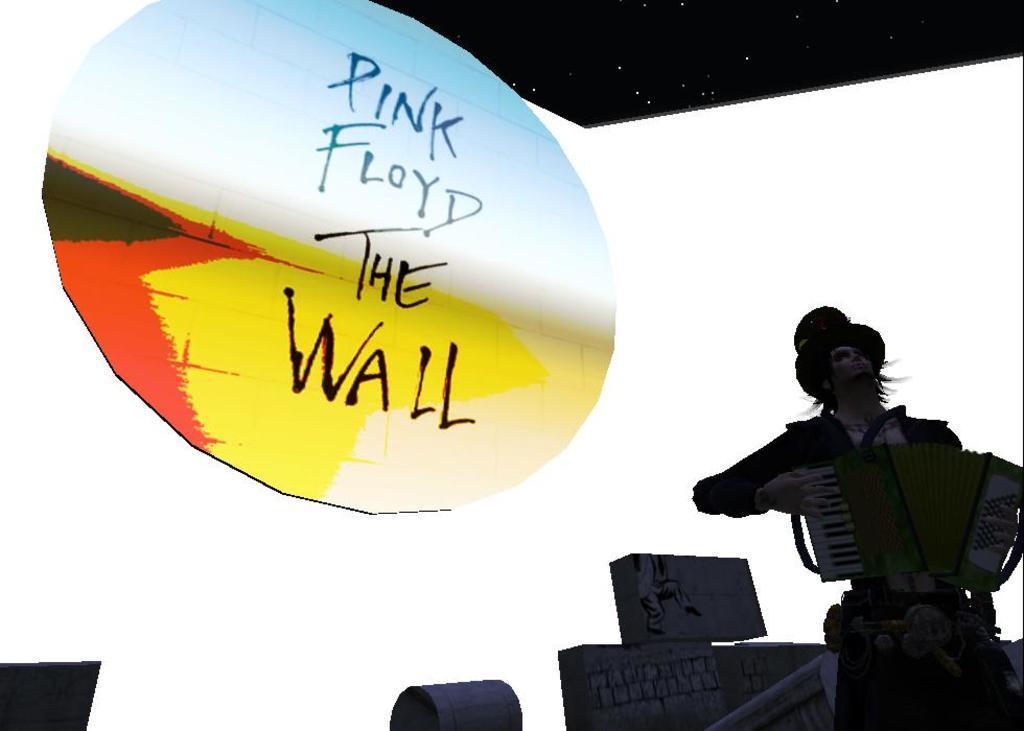What type of picture is in the image? There is an animated picture in the image. What is happening in the animated picture? A person is standing in the animated picture, holding a musical instrument. What can be seen in the animated picture besides the person? There is a huge board in the animated picture, with a white surface. How is the sky depicted in the animated picture? The sky in the animated picture is dark. What type of liquid is being poured on the person's legs in the image? There is no liquid being poured on the person's legs in the image, as the provided facts do not mention any such activity. 